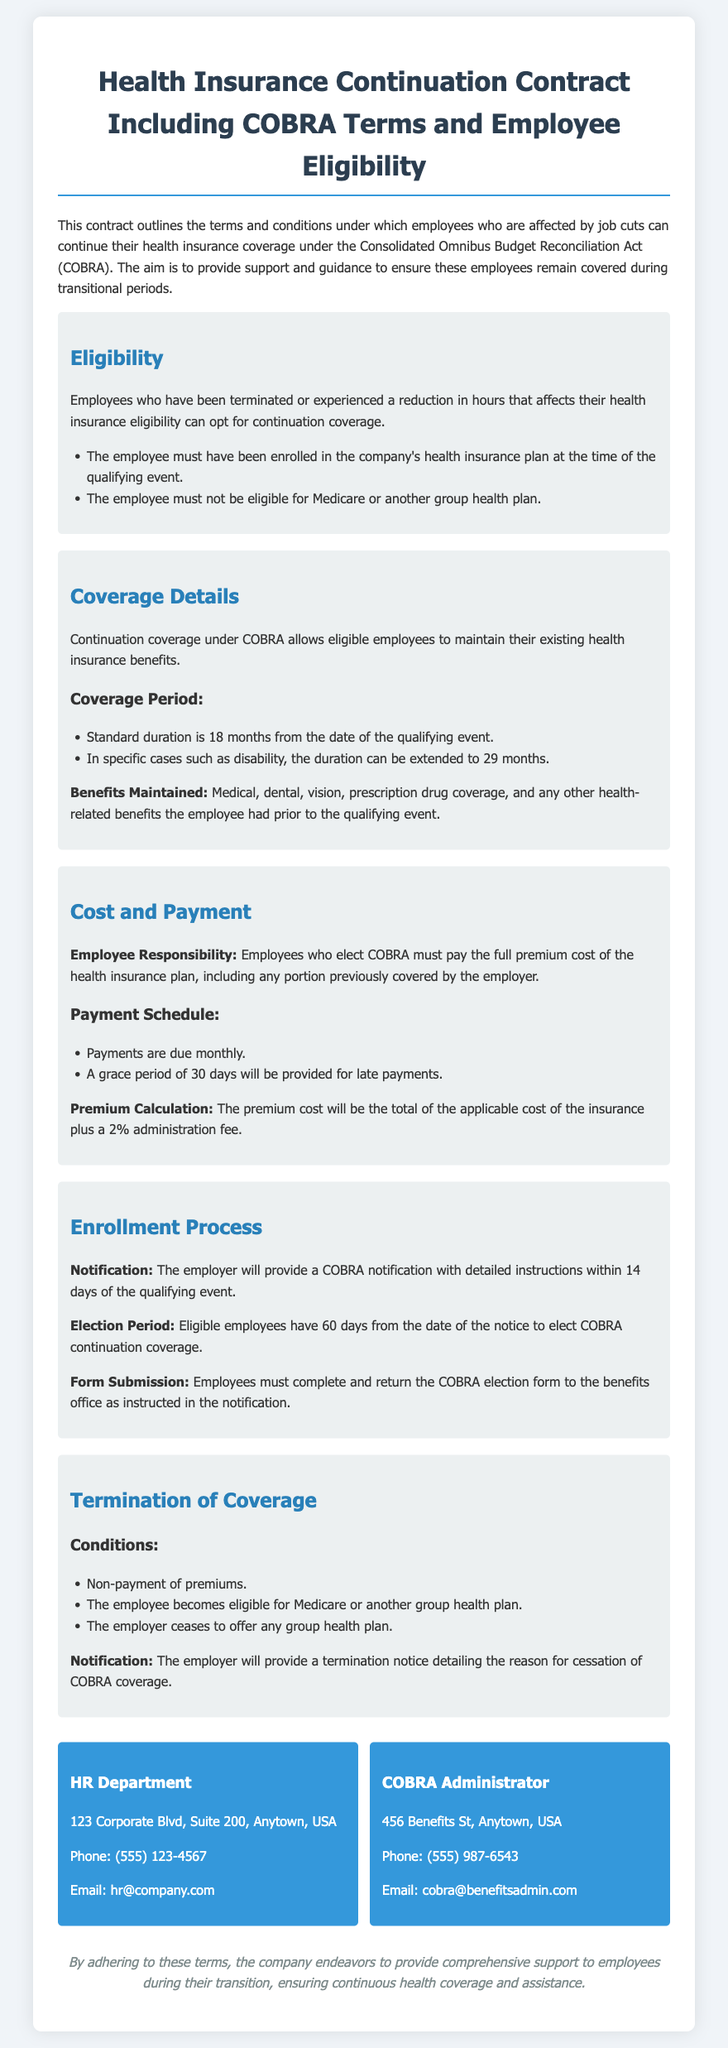What is COBRA? COBRA stands for the Consolidated Omnibus Budget Reconciliation Act, which allows employees to continue their health insurance coverage after job cuts.
Answer: Consolidated Omnibus Budget Reconciliation Act Who is eligible for continuation coverage? Employees eligible for continuation coverage are those who have been terminated or have a reduction in hours affecting their health insurance eligibility.
Answer: Terminated or reduced hours employees What is the standard coverage duration under COBRA? The standard coverage duration under COBRA is typically 18 months from the date of the qualifying event.
Answer: 18 months What is the cost responsibility for the employee? Employees who elect COBRA must pay the full premium cost of the health insurance plan, including any portion previously covered by the employer.
Answer: Full premium cost How long do employees have to elect COBRA continuation coverage? Eligible employees have 60 days from the date of the notice to elect COBRA continuation coverage.
Answer: 60 days What happens if premiums are not paid? Non-payment of premiums is one of the conditions under which COBRA coverage can be terminated.
Answer: Non-payment of premiums What is included in the benefits maintained? Benefits maintained include medical, dental, vision, prescription drug coverage, and any other health-related benefits prior to the qualifying event.
Answer: Medical, dental, vision, prescription drug coverage Who should employees contact for more information? Employees can contact either the HR Department or the COBRA Administrator for more information regarding their health insurance continuation.
Answer: HR Department or COBRA Administrator 